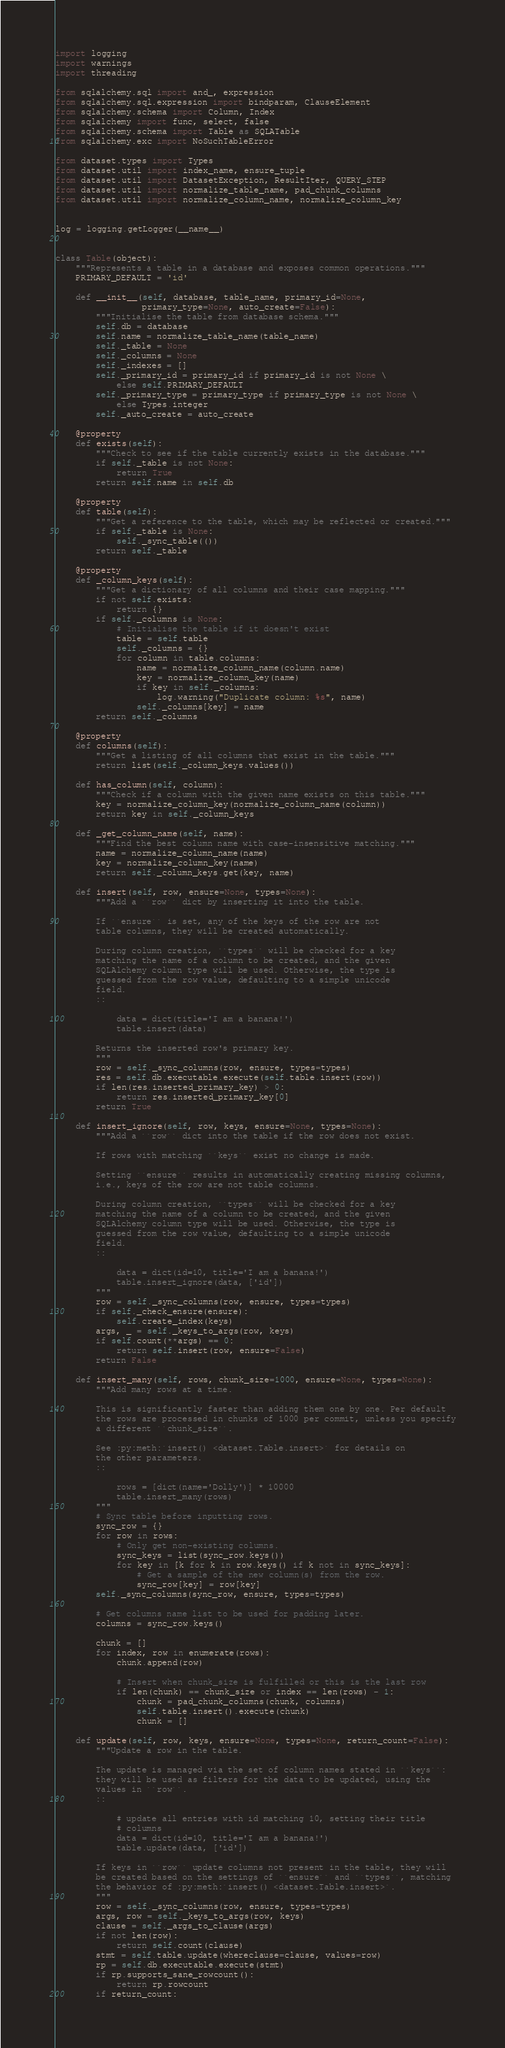Convert code to text. <code><loc_0><loc_0><loc_500><loc_500><_Python_>import logging
import warnings
import threading

from sqlalchemy.sql import and_, expression
from sqlalchemy.sql.expression import bindparam, ClauseElement
from sqlalchemy.schema import Column, Index
from sqlalchemy import func, select, false
from sqlalchemy.schema import Table as SQLATable
from sqlalchemy.exc import NoSuchTableError

from dataset.types import Types
from dataset.util import index_name, ensure_tuple
from dataset.util import DatasetException, ResultIter, QUERY_STEP
from dataset.util import normalize_table_name, pad_chunk_columns
from dataset.util import normalize_column_name, normalize_column_key


log = logging.getLogger(__name__)


class Table(object):
    """Represents a table in a database and exposes common operations."""
    PRIMARY_DEFAULT = 'id'

    def __init__(self, database, table_name, primary_id=None,
                 primary_type=None, auto_create=False):
        """Initialise the table from database schema."""
        self.db = database
        self.name = normalize_table_name(table_name)
        self._table = None
        self._columns = None
        self._indexes = []
        self._primary_id = primary_id if primary_id is not None \
            else self.PRIMARY_DEFAULT
        self._primary_type = primary_type if primary_type is not None \
            else Types.integer
        self._auto_create = auto_create

    @property
    def exists(self):
        """Check to see if the table currently exists in the database."""
        if self._table is not None:
            return True
        return self.name in self.db

    @property
    def table(self):
        """Get a reference to the table, which may be reflected or created."""
        if self._table is None:
            self._sync_table(())
        return self._table

    @property
    def _column_keys(self):
        """Get a dictionary of all columns and their case mapping."""
        if not self.exists:
            return {}
        if self._columns is None:
            # Initialise the table if it doesn't exist
            table = self.table
            self._columns = {}
            for column in table.columns:
                name = normalize_column_name(column.name)
                key = normalize_column_key(name)
                if key in self._columns:
                    log.warning("Duplicate column: %s", name)
                self._columns[key] = name
        return self._columns

    @property
    def columns(self):
        """Get a listing of all columns that exist in the table."""
        return list(self._column_keys.values())

    def has_column(self, column):
        """Check if a column with the given name exists on this table."""
        key = normalize_column_key(normalize_column_name(column))
        return key in self._column_keys

    def _get_column_name(self, name):
        """Find the best column name with case-insensitive matching."""
        name = normalize_column_name(name)
        key = normalize_column_key(name)
        return self._column_keys.get(key, name)

    def insert(self, row, ensure=None, types=None):
        """Add a ``row`` dict by inserting it into the table.

        If ``ensure`` is set, any of the keys of the row are not
        table columns, they will be created automatically.

        During column creation, ``types`` will be checked for a key
        matching the name of a column to be created, and the given
        SQLAlchemy column type will be used. Otherwise, the type is
        guessed from the row value, defaulting to a simple unicode
        field.
        ::

            data = dict(title='I am a banana!')
            table.insert(data)

        Returns the inserted row's primary key.
        """
        row = self._sync_columns(row, ensure, types=types)
        res = self.db.executable.execute(self.table.insert(row))
        if len(res.inserted_primary_key) > 0:
            return res.inserted_primary_key[0]
        return True

    def insert_ignore(self, row, keys, ensure=None, types=None):
        """Add a ``row`` dict into the table if the row does not exist.

        If rows with matching ``keys`` exist no change is made.

        Setting ``ensure`` results in automatically creating missing columns,
        i.e., keys of the row are not table columns.

        During column creation, ``types`` will be checked for a key
        matching the name of a column to be created, and the given
        SQLAlchemy column type will be used. Otherwise, the type is
        guessed from the row value, defaulting to a simple unicode
        field.
        ::

            data = dict(id=10, title='I am a banana!')
            table.insert_ignore(data, ['id'])
        """
        row = self._sync_columns(row, ensure, types=types)
        if self._check_ensure(ensure):
            self.create_index(keys)
        args, _ = self._keys_to_args(row, keys)
        if self.count(**args) == 0:
            return self.insert(row, ensure=False)
        return False

    def insert_many(self, rows, chunk_size=1000, ensure=None, types=None):
        """Add many rows at a time.

        This is significantly faster than adding them one by one. Per default
        the rows are processed in chunks of 1000 per commit, unless you specify
        a different ``chunk_size``.

        See :py:meth:`insert() <dataset.Table.insert>` for details on
        the other parameters.
        ::

            rows = [dict(name='Dolly')] * 10000
            table.insert_many(rows)
        """
        # Sync table before inputting rows.
        sync_row = {}
        for row in rows:
            # Only get non-existing columns.
            sync_keys = list(sync_row.keys())
            for key in [k for k in row.keys() if k not in sync_keys]:
                # Get a sample of the new column(s) from the row.
                sync_row[key] = row[key]
        self._sync_columns(sync_row, ensure, types=types)

        # Get columns name list to be used for padding later.
        columns = sync_row.keys()

        chunk = []
        for index, row in enumerate(rows):
            chunk.append(row)

            # Insert when chunk_size is fulfilled or this is the last row
            if len(chunk) == chunk_size or index == len(rows) - 1:
                chunk = pad_chunk_columns(chunk, columns)
                self.table.insert().execute(chunk)
                chunk = []

    def update(self, row, keys, ensure=None, types=None, return_count=False):
        """Update a row in the table.

        The update is managed via the set of column names stated in ``keys``:
        they will be used as filters for the data to be updated, using the
        values in ``row``.
        ::

            # update all entries with id matching 10, setting their title
            # columns
            data = dict(id=10, title='I am a banana!')
            table.update(data, ['id'])

        If keys in ``row`` update columns not present in the table, they will
        be created based on the settings of ``ensure`` and ``types``, matching
        the behavior of :py:meth:`insert() <dataset.Table.insert>`.
        """
        row = self._sync_columns(row, ensure, types=types)
        args, row = self._keys_to_args(row, keys)
        clause = self._args_to_clause(args)
        if not len(row):
            return self.count(clause)
        stmt = self.table.update(whereclause=clause, values=row)
        rp = self.db.executable.execute(stmt)
        if rp.supports_sane_rowcount():
            return rp.rowcount
        if return_count:</code> 